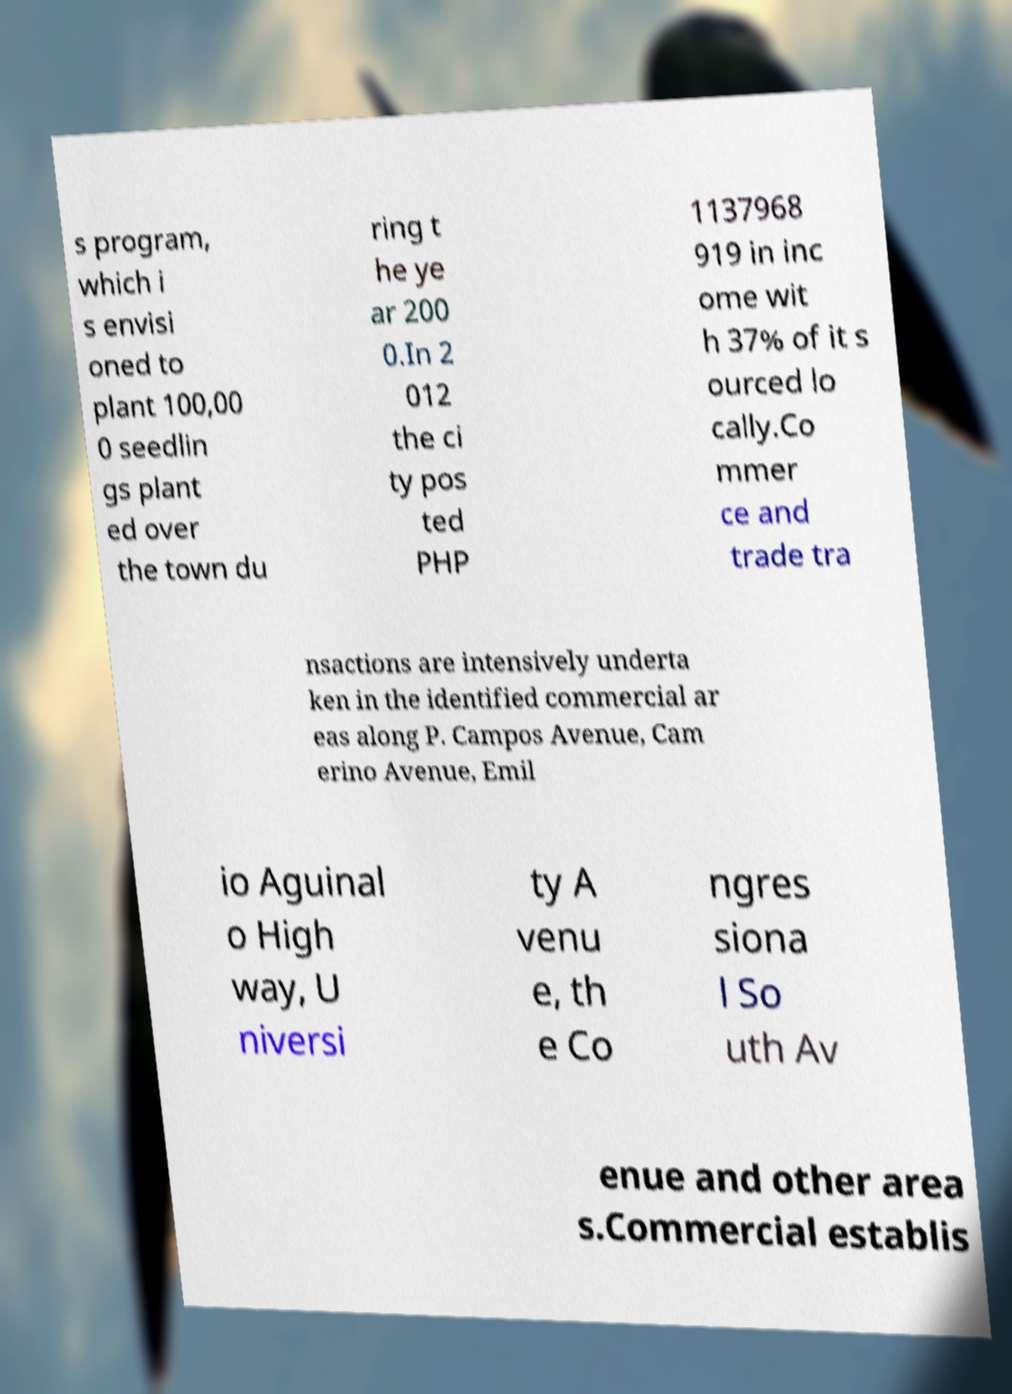Could you assist in decoding the text presented in this image and type it out clearly? s program, which i s envisi oned to plant 100,00 0 seedlin gs plant ed over the town du ring t he ye ar 200 0.In 2 012 the ci ty pos ted PHP 1137968 919 in inc ome wit h 37% of it s ourced lo cally.Co mmer ce and trade tra nsactions are intensively underta ken in the identified commercial ar eas along P. Campos Avenue, Cam erino Avenue, Emil io Aguinal o High way, U niversi ty A venu e, th e Co ngres siona l So uth Av enue and other area s.Commercial establis 